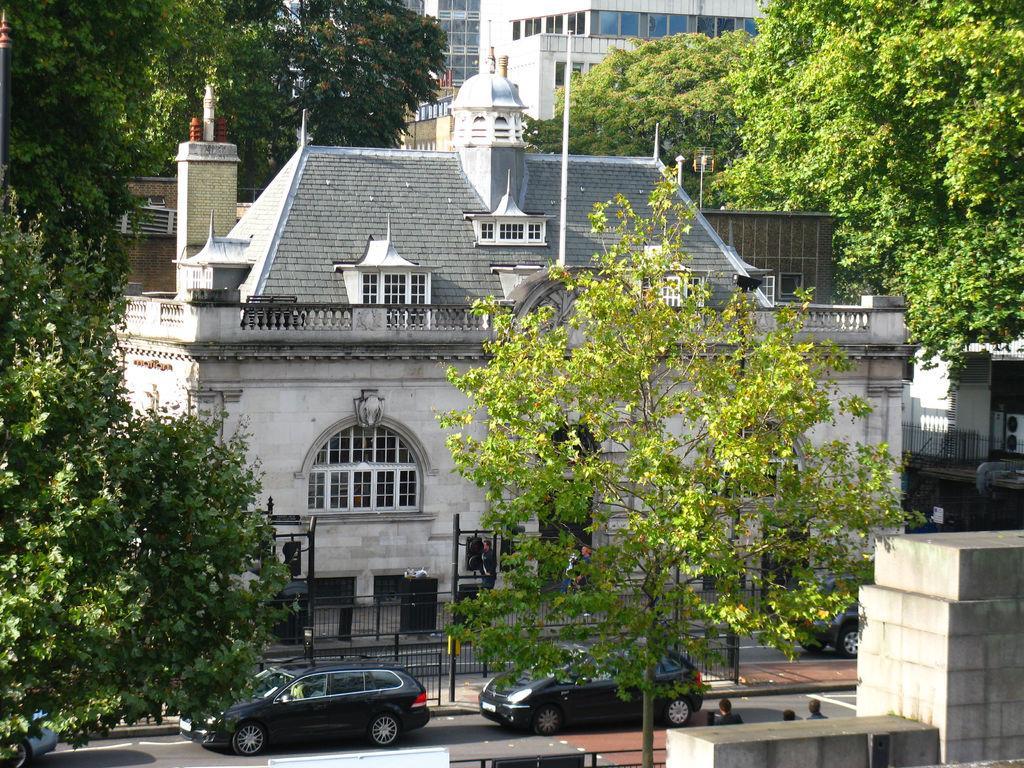How would you summarize this image in a sentence or two? In this image there are cars on the road, beside the road there are a few people standing on the pavement, on the pavement there are traffic lights, lamp posts. In the background of the image there are trees and buildings. 